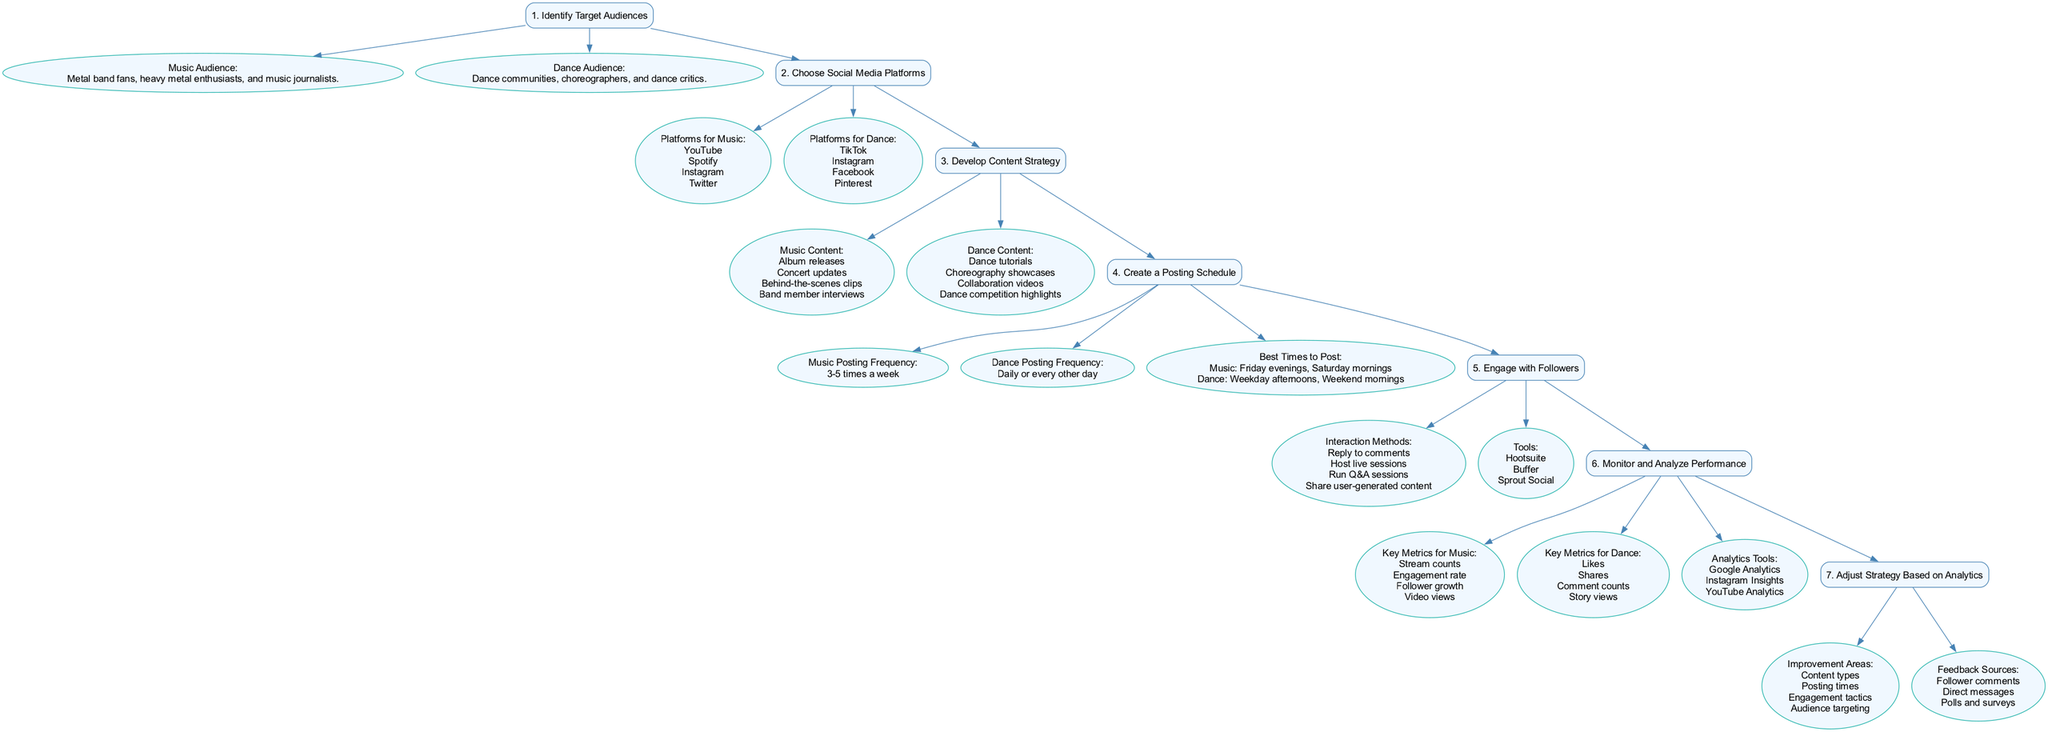What are the two main target audiences identified? The diagram lists two main target audiences: the music audience, which includes metal band fans, heavy metal enthusiasts, and music journalists, and the dance audience, which includes dance communities, choreographers, and dance critics.
Answer: Music audience and Dance audience How many platforms are suggested for the dance audience? The diagram indicates that four social media platforms are suggested for the dance audience: TikTok, Instagram, Facebook, and Pinterest.
Answer: Four What is the posting frequency for the music audience? According to the diagram, the recommended posting frequency for the music audience is stated as 3-5 times a week.
Answer: 3-5 times a week What content type is included for both music and dance? The diagram shows that both music and dance content categories include "Collaboration videos," which appear under dance but could logically have parallels under music as well—indicating a thematic overlap.
Answer: Collaboration videos Which analytics tools are suggested for monitoring dance performance? The diagram notes that the suggested analytics tools for monitoring dance performance include Google Analytics, Instagram Insights, and YouTube Analytics, providing multiple options for analysis.
Answer: Google Analytics, Instagram Insights, YouTube Analytics What are two improvement areas when adjusting strategy based on analytics? The diagram lists multiple improvement areas, including "Content types" and "Engagement tactics," which can be prioritized for enhancing social media strategies.
Answer: Content types and Engagement tactics What is the best time to post for the dance audience? The diagram indicates that the best times to post for the dance audience are weekday afternoons and weekend mornings, providing guidance for optimal engagement.
Answer: Weekday afternoons and Weekend mornings How do you engage with followers according to the diagram? Interaction methods provided in the diagram for engaging with followers include replying to comments, hosting live sessions, running Q&A sessions, and sharing user-generated content.
Answer: Reply to comments, Host live sessions, Run Q&A sessions, Share user-generated content How many key metrics are listed for analyzing music performance? The diagram states that there are four key metrics for analyzing music performance, which are stream counts, engagement rate, follower growth, and video views.
Answer: Four 